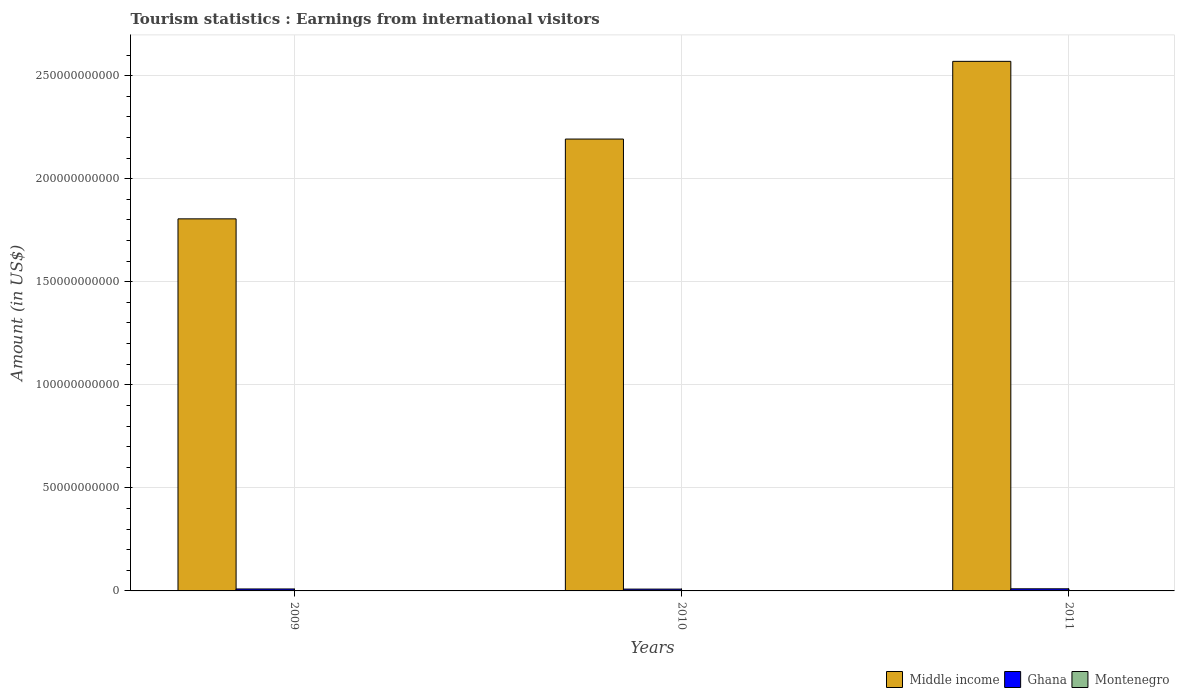How many bars are there on the 1st tick from the right?
Your answer should be compact. 3. What is the label of the 1st group of bars from the left?
Provide a succinct answer. 2009. What is the earnings from international visitors in Montenegro in 2011?
Your response must be concise. 7.00e+07. Across all years, what is the maximum earnings from international visitors in Ghana?
Your answer should be compact. 1.03e+09. Across all years, what is the minimum earnings from international visitors in Montenegro?
Provide a short and direct response. 7.00e+07. What is the total earnings from international visitors in Ghana in the graph?
Your answer should be compact. 2.86e+09. What is the difference between the earnings from international visitors in Middle income in 2010 and that in 2011?
Give a very brief answer. -3.77e+1. What is the difference between the earnings from international visitors in Middle income in 2011 and the earnings from international visitors in Montenegro in 2010?
Provide a succinct answer. 2.57e+11. What is the average earnings from international visitors in Montenegro per year?
Your answer should be compact. 7.27e+07. In the year 2011, what is the difference between the earnings from international visitors in Middle income and earnings from international visitors in Montenegro?
Provide a short and direct response. 2.57e+11. What is the ratio of the earnings from international visitors in Middle income in 2009 to that in 2010?
Make the answer very short. 0.82. Is the earnings from international visitors in Ghana in 2010 less than that in 2011?
Your answer should be very brief. Yes. What is the difference between the highest and the second highest earnings from international visitors in Middle income?
Keep it short and to the point. 3.77e+1. What is the difference between the highest and the lowest earnings from international visitors in Middle income?
Your answer should be very brief. 7.64e+1. Is the sum of the earnings from international visitors in Montenegro in 2009 and 2011 greater than the maximum earnings from international visitors in Ghana across all years?
Offer a terse response. No. What does the 3rd bar from the left in 2010 represents?
Offer a terse response. Montenegro. Is it the case that in every year, the sum of the earnings from international visitors in Middle income and earnings from international visitors in Montenegro is greater than the earnings from international visitors in Ghana?
Give a very brief answer. Yes. Are all the bars in the graph horizontal?
Give a very brief answer. No. How many years are there in the graph?
Your response must be concise. 3. What is the difference between two consecutive major ticks on the Y-axis?
Provide a short and direct response. 5.00e+1. Does the graph contain any zero values?
Your response must be concise. No. Does the graph contain grids?
Keep it short and to the point. Yes. How are the legend labels stacked?
Your response must be concise. Horizontal. What is the title of the graph?
Make the answer very short. Tourism statistics : Earnings from international visitors. Does "Mauritius" appear as one of the legend labels in the graph?
Your answer should be compact. No. What is the label or title of the Y-axis?
Ensure brevity in your answer.  Amount (in US$). What is the Amount (in US$) in Middle income in 2009?
Your answer should be very brief. 1.81e+11. What is the Amount (in US$) of Ghana in 2009?
Your answer should be compact. 9.48e+08. What is the Amount (in US$) of Montenegro in 2009?
Ensure brevity in your answer.  7.60e+07. What is the Amount (in US$) of Middle income in 2010?
Offer a very short reply. 2.19e+11. What is the Amount (in US$) in Ghana in 2010?
Provide a short and direct response. 8.82e+08. What is the Amount (in US$) in Montenegro in 2010?
Offer a very short reply. 7.20e+07. What is the Amount (in US$) in Middle income in 2011?
Your response must be concise. 2.57e+11. What is the Amount (in US$) in Ghana in 2011?
Provide a succinct answer. 1.03e+09. What is the Amount (in US$) in Montenegro in 2011?
Keep it short and to the point. 7.00e+07. Across all years, what is the maximum Amount (in US$) in Middle income?
Give a very brief answer. 2.57e+11. Across all years, what is the maximum Amount (in US$) of Ghana?
Make the answer very short. 1.03e+09. Across all years, what is the maximum Amount (in US$) in Montenegro?
Make the answer very short. 7.60e+07. Across all years, what is the minimum Amount (in US$) of Middle income?
Give a very brief answer. 1.81e+11. Across all years, what is the minimum Amount (in US$) of Ghana?
Your answer should be very brief. 8.82e+08. Across all years, what is the minimum Amount (in US$) of Montenegro?
Give a very brief answer. 7.00e+07. What is the total Amount (in US$) in Middle income in the graph?
Ensure brevity in your answer.  6.57e+11. What is the total Amount (in US$) of Ghana in the graph?
Give a very brief answer. 2.86e+09. What is the total Amount (in US$) of Montenegro in the graph?
Make the answer very short. 2.18e+08. What is the difference between the Amount (in US$) in Middle income in 2009 and that in 2010?
Provide a short and direct response. -3.87e+1. What is the difference between the Amount (in US$) in Ghana in 2009 and that in 2010?
Keep it short and to the point. 6.60e+07. What is the difference between the Amount (in US$) of Middle income in 2009 and that in 2011?
Offer a very short reply. -7.64e+1. What is the difference between the Amount (in US$) in Ghana in 2009 and that in 2011?
Give a very brief answer. -7.80e+07. What is the difference between the Amount (in US$) in Montenegro in 2009 and that in 2011?
Keep it short and to the point. 6.00e+06. What is the difference between the Amount (in US$) of Middle income in 2010 and that in 2011?
Your answer should be very brief. -3.77e+1. What is the difference between the Amount (in US$) in Ghana in 2010 and that in 2011?
Your answer should be compact. -1.44e+08. What is the difference between the Amount (in US$) of Montenegro in 2010 and that in 2011?
Give a very brief answer. 2.00e+06. What is the difference between the Amount (in US$) of Middle income in 2009 and the Amount (in US$) of Ghana in 2010?
Your response must be concise. 1.80e+11. What is the difference between the Amount (in US$) of Middle income in 2009 and the Amount (in US$) of Montenegro in 2010?
Keep it short and to the point. 1.80e+11. What is the difference between the Amount (in US$) of Ghana in 2009 and the Amount (in US$) of Montenegro in 2010?
Your response must be concise. 8.76e+08. What is the difference between the Amount (in US$) in Middle income in 2009 and the Amount (in US$) in Ghana in 2011?
Offer a terse response. 1.79e+11. What is the difference between the Amount (in US$) of Middle income in 2009 and the Amount (in US$) of Montenegro in 2011?
Keep it short and to the point. 1.80e+11. What is the difference between the Amount (in US$) in Ghana in 2009 and the Amount (in US$) in Montenegro in 2011?
Give a very brief answer. 8.78e+08. What is the difference between the Amount (in US$) in Middle income in 2010 and the Amount (in US$) in Ghana in 2011?
Provide a short and direct response. 2.18e+11. What is the difference between the Amount (in US$) in Middle income in 2010 and the Amount (in US$) in Montenegro in 2011?
Your answer should be compact. 2.19e+11. What is the difference between the Amount (in US$) in Ghana in 2010 and the Amount (in US$) in Montenegro in 2011?
Offer a terse response. 8.12e+08. What is the average Amount (in US$) of Middle income per year?
Offer a very short reply. 2.19e+11. What is the average Amount (in US$) in Ghana per year?
Your answer should be compact. 9.52e+08. What is the average Amount (in US$) in Montenegro per year?
Ensure brevity in your answer.  7.27e+07. In the year 2009, what is the difference between the Amount (in US$) of Middle income and Amount (in US$) of Ghana?
Your answer should be very brief. 1.80e+11. In the year 2009, what is the difference between the Amount (in US$) of Middle income and Amount (in US$) of Montenegro?
Ensure brevity in your answer.  1.80e+11. In the year 2009, what is the difference between the Amount (in US$) of Ghana and Amount (in US$) of Montenegro?
Offer a terse response. 8.72e+08. In the year 2010, what is the difference between the Amount (in US$) in Middle income and Amount (in US$) in Ghana?
Your answer should be compact. 2.18e+11. In the year 2010, what is the difference between the Amount (in US$) in Middle income and Amount (in US$) in Montenegro?
Offer a terse response. 2.19e+11. In the year 2010, what is the difference between the Amount (in US$) of Ghana and Amount (in US$) of Montenegro?
Your response must be concise. 8.10e+08. In the year 2011, what is the difference between the Amount (in US$) in Middle income and Amount (in US$) in Ghana?
Provide a short and direct response. 2.56e+11. In the year 2011, what is the difference between the Amount (in US$) of Middle income and Amount (in US$) of Montenegro?
Make the answer very short. 2.57e+11. In the year 2011, what is the difference between the Amount (in US$) in Ghana and Amount (in US$) in Montenegro?
Provide a succinct answer. 9.56e+08. What is the ratio of the Amount (in US$) in Middle income in 2009 to that in 2010?
Your answer should be compact. 0.82. What is the ratio of the Amount (in US$) of Ghana in 2009 to that in 2010?
Provide a succinct answer. 1.07. What is the ratio of the Amount (in US$) in Montenegro in 2009 to that in 2010?
Keep it short and to the point. 1.06. What is the ratio of the Amount (in US$) of Middle income in 2009 to that in 2011?
Keep it short and to the point. 0.7. What is the ratio of the Amount (in US$) in Ghana in 2009 to that in 2011?
Your answer should be very brief. 0.92. What is the ratio of the Amount (in US$) of Montenegro in 2009 to that in 2011?
Your answer should be very brief. 1.09. What is the ratio of the Amount (in US$) of Middle income in 2010 to that in 2011?
Provide a short and direct response. 0.85. What is the ratio of the Amount (in US$) of Ghana in 2010 to that in 2011?
Provide a succinct answer. 0.86. What is the ratio of the Amount (in US$) in Montenegro in 2010 to that in 2011?
Provide a succinct answer. 1.03. What is the difference between the highest and the second highest Amount (in US$) in Middle income?
Give a very brief answer. 3.77e+1. What is the difference between the highest and the second highest Amount (in US$) in Ghana?
Your answer should be very brief. 7.80e+07. What is the difference between the highest and the second highest Amount (in US$) of Montenegro?
Give a very brief answer. 4.00e+06. What is the difference between the highest and the lowest Amount (in US$) in Middle income?
Provide a succinct answer. 7.64e+1. What is the difference between the highest and the lowest Amount (in US$) of Ghana?
Offer a terse response. 1.44e+08. 